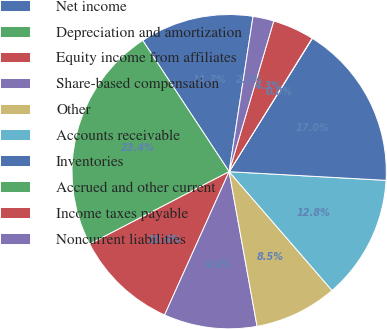<chart> <loc_0><loc_0><loc_500><loc_500><pie_chart><fcel>Net income<fcel>Depreciation and amortization<fcel>Equity income from affiliates<fcel>Share-based compensation<fcel>Other<fcel>Accounts receivable<fcel>Inventories<fcel>Accrued and other current<fcel>Income taxes payable<fcel>Noncurrent liabilities<nl><fcel>11.7%<fcel>23.36%<fcel>10.64%<fcel>9.58%<fcel>8.52%<fcel>12.76%<fcel>17.0%<fcel>0.03%<fcel>4.27%<fcel>2.15%<nl></chart> 